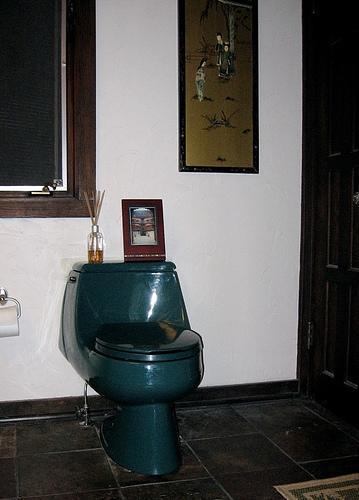How many pictures can you see?
Give a very brief answer. 2. 